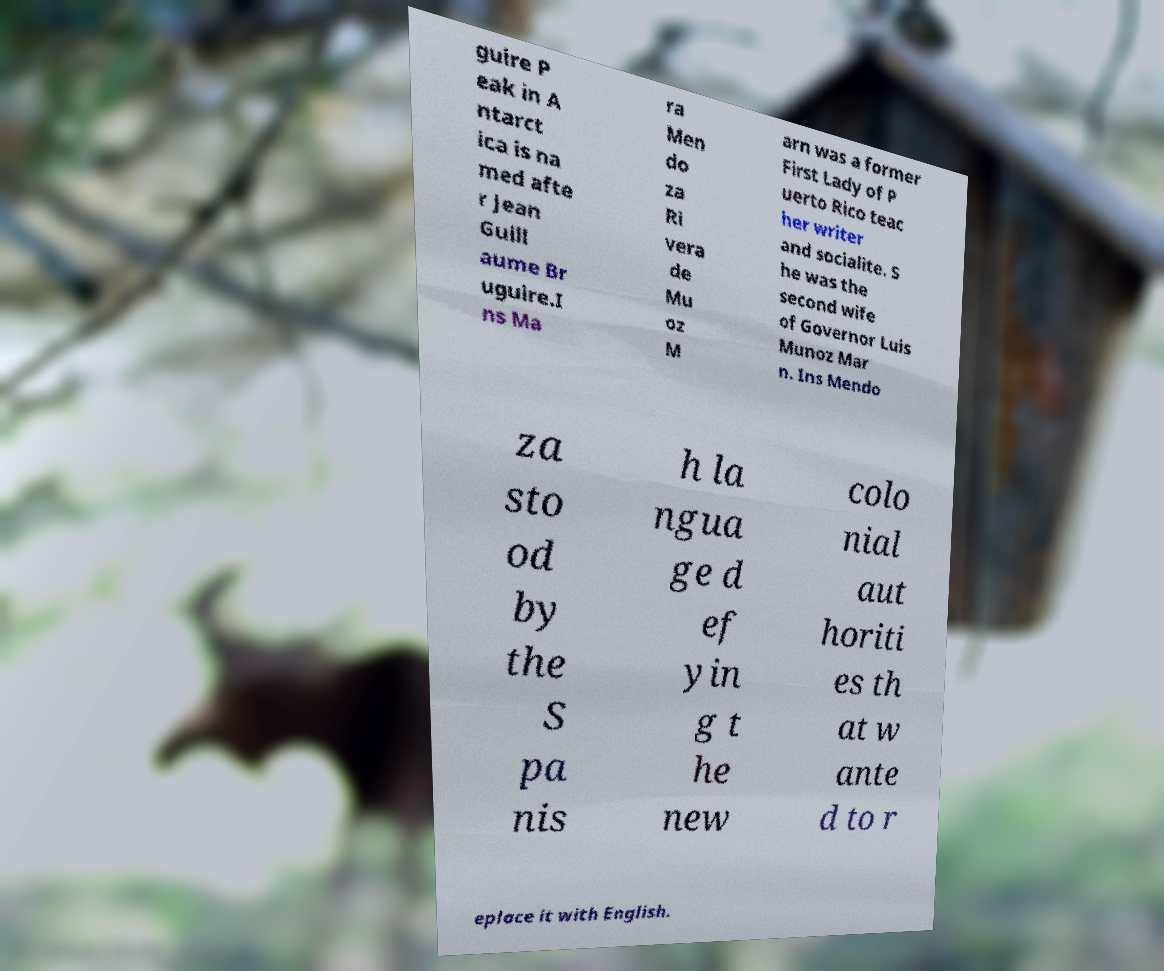For documentation purposes, I need the text within this image transcribed. Could you provide that? guire P eak in A ntarct ica is na med afte r Jean Guill aume Br uguire.I ns Ma ra Men do za Ri vera de Mu oz M arn was a former First Lady of P uerto Rico teac her writer and socialite. S he was the second wife of Governor Luis Munoz Mar n. Ins Mendo za sto od by the S pa nis h la ngua ge d ef yin g t he new colo nial aut horiti es th at w ante d to r eplace it with English. 